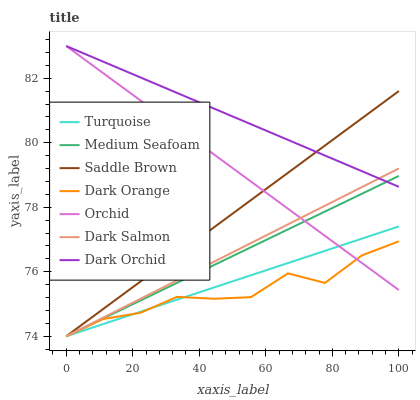Does Dark Orange have the minimum area under the curve?
Answer yes or no. Yes. Does Dark Orchid have the maximum area under the curve?
Answer yes or no. Yes. Does Turquoise have the minimum area under the curve?
Answer yes or no. No. Does Turquoise have the maximum area under the curve?
Answer yes or no. No. Is Orchid the smoothest?
Answer yes or no. Yes. Is Dark Orange the roughest?
Answer yes or no. Yes. Is Turquoise the smoothest?
Answer yes or no. No. Is Turquoise the roughest?
Answer yes or no. No. Does Dark Orange have the lowest value?
Answer yes or no. Yes. Does Dark Orchid have the lowest value?
Answer yes or no. No. Does Orchid have the highest value?
Answer yes or no. Yes. Does Turquoise have the highest value?
Answer yes or no. No. Is Turquoise less than Dark Orchid?
Answer yes or no. Yes. Is Dark Orchid greater than Dark Orange?
Answer yes or no. Yes. Does Dark Salmon intersect Turquoise?
Answer yes or no. Yes. Is Dark Salmon less than Turquoise?
Answer yes or no. No. Is Dark Salmon greater than Turquoise?
Answer yes or no. No. Does Turquoise intersect Dark Orchid?
Answer yes or no. No. 